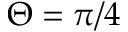<formula> <loc_0><loc_0><loc_500><loc_500>\Theta = \pi / 4</formula> 